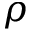<formula> <loc_0><loc_0><loc_500><loc_500>\rho</formula> 